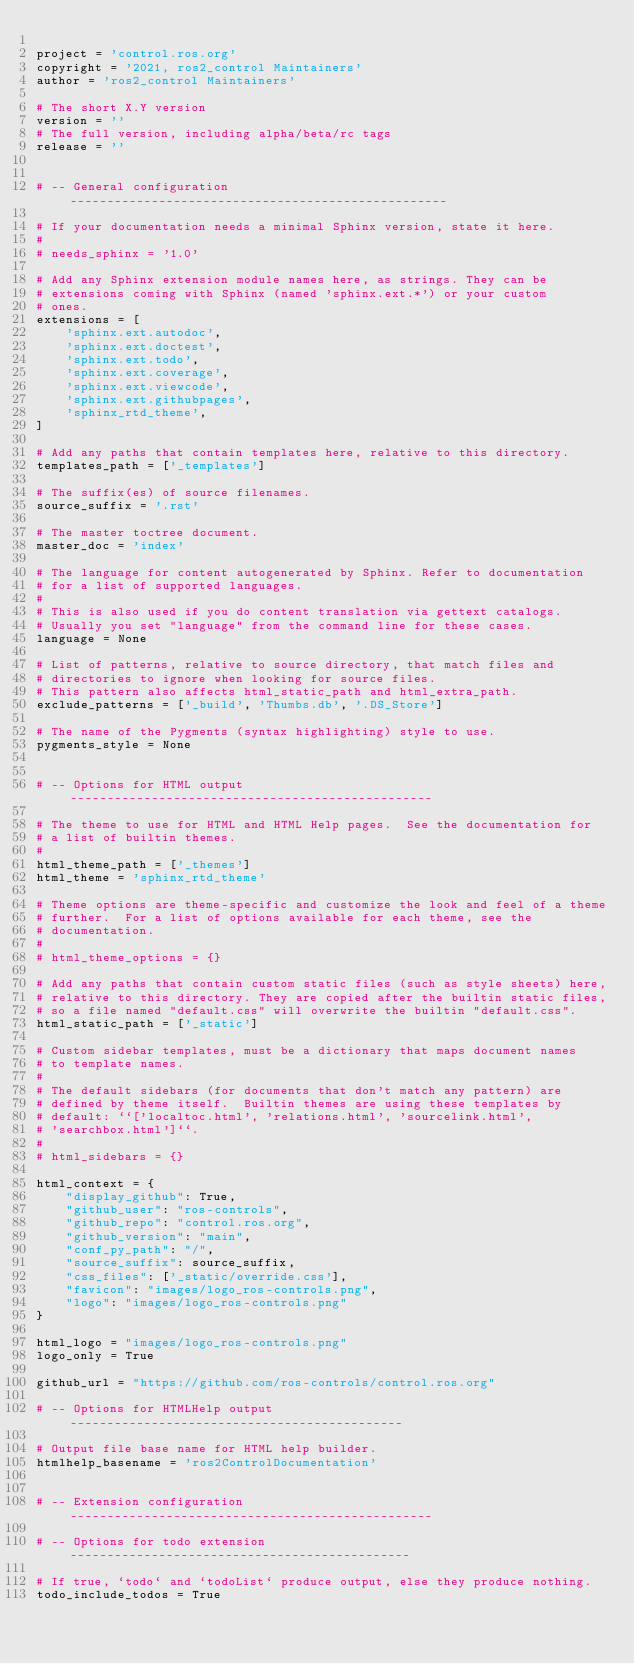Convert code to text. <code><loc_0><loc_0><loc_500><loc_500><_Python_>
project = 'control.ros.org'
copyright = '2021, ros2_control Maintainers'
author = 'ros2_control Maintainers'

# The short X.Y version
version = ''
# The full version, including alpha/beta/rc tags
release = ''


# -- General configuration ---------------------------------------------------

# If your documentation needs a minimal Sphinx version, state it here.
#
# needs_sphinx = '1.0'

# Add any Sphinx extension module names here, as strings. They can be
# extensions coming with Sphinx (named 'sphinx.ext.*') or your custom
# ones.
extensions = [
    'sphinx.ext.autodoc',
    'sphinx.ext.doctest',
    'sphinx.ext.todo',
    'sphinx.ext.coverage',
    'sphinx.ext.viewcode',
    'sphinx.ext.githubpages',
    'sphinx_rtd_theme',
]

# Add any paths that contain templates here, relative to this directory.
templates_path = ['_templates']

# The suffix(es) of source filenames.
source_suffix = '.rst'

# The master toctree document.
master_doc = 'index'

# The language for content autogenerated by Sphinx. Refer to documentation
# for a list of supported languages.
#
# This is also used if you do content translation via gettext catalogs.
# Usually you set "language" from the command line for these cases.
language = None

# List of patterns, relative to source directory, that match files and
# directories to ignore when looking for source files.
# This pattern also affects html_static_path and html_extra_path.
exclude_patterns = ['_build', 'Thumbs.db', '.DS_Store']

# The name of the Pygments (syntax highlighting) style to use.
pygments_style = None


# -- Options for HTML output -------------------------------------------------

# The theme to use for HTML and HTML Help pages.  See the documentation for
# a list of builtin themes.
#
html_theme_path = ['_themes']
html_theme = 'sphinx_rtd_theme'

# Theme options are theme-specific and customize the look and feel of a theme
# further.  For a list of options available for each theme, see the
# documentation.
#
# html_theme_options = {}

# Add any paths that contain custom static files (such as style sheets) here,
# relative to this directory. They are copied after the builtin static files,
# so a file named "default.css" will overwrite the builtin "default.css".
html_static_path = ['_static']

# Custom sidebar templates, must be a dictionary that maps document names
# to template names.
#
# The default sidebars (for documents that don't match any pattern) are
# defined by theme itself.  Builtin themes are using these templates by
# default: ``['localtoc.html', 'relations.html', 'sourcelink.html',
# 'searchbox.html']``.
#
# html_sidebars = {}

html_context = {
    "display_github": True,
    "github_user": "ros-controls",
    "github_repo": "control.ros.org",
    "github_version": "main",
    "conf_py_path": "/",
    "source_suffix": source_suffix,
    "css_files": ['_static/override.css'],
    "favicon": "images/logo_ros-controls.png",
    "logo": "images/logo_ros-controls.png"
}

html_logo = "images/logo_ros-controls.png"
logo_only = True

github_url = "https://github.com/ros-controls/control.ros.org"

# -- Options for HTMLHelp output ---------------------------------------------

# Output file base name for HTML help builder.
htmlhelp_basename = 'ros2ControlDocumentation'


# -- Extension configuration -------------------------------------------------

# -- Options for todo extension ----------------------------------------------

# If true, `todo` and `todoList` produce output, else they produce nothing.
todo_include_todos = True
</code> 